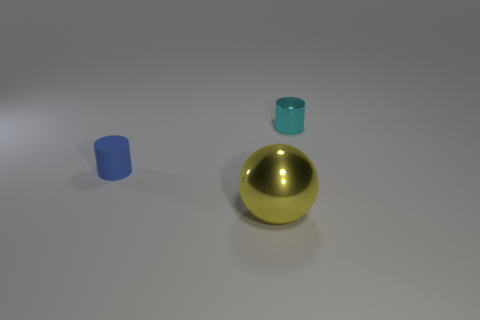What is the shape of the cyan object?
Provide a succinct answer. Cylinder. Are there any cyan cylinders that have the same size as the blue matte cylinder?
Give a very brief answer. Yes. What material is the thing that is the same size as the cyan metal cylinder?
Make the answer very short. Rubber. What is the size of the metallic object behind the metallic object that is left of the tiny cyan cylinder?
Keep it short and to the point. Small. Does the metallic thing that is behind the sphere have the same size as the blue cylinder?
Provide a short and direct response. Yes. Is the number of big metal balls to the right of the cyan metallic cylinder greater than the number of metal spheres on the right side of the shiny ball?
Give a very brief answer. No. There is a thing that is on the right side of the blue rubber thing and behind the yellow metal sphere; what is its shape?
Give a very brief answer. Cylinder. What is the shape of the metal object that is on the right side of the yellow object?
Your answer should be compact. Cylinder. There is a thing on the left side of the metal object in front of the metallic object on the right side of the yellow metal thing; what size is it?
Provide a short and direct response. Small. Is the shape of the small blue rubber object the same as the cyan shiny thing?
Give a very brief answer. Yes. 